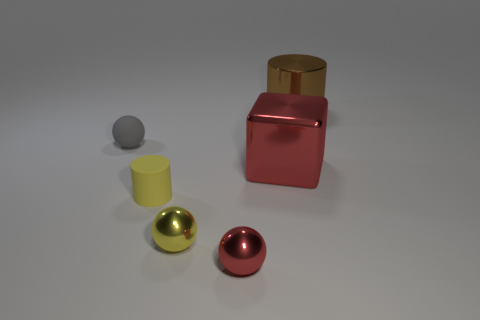There is a small thing that is the same color as the matte cylinder; what is its shape?
Ensure brevity in your answer.  Sphere. There is a tiny red metal object; is its shape the same as the matte thing that is behind the small rubber cylinder?
Your answer should be very brief. Yes. The metal thing that is both in front of the large brown shiny thing and behind the yellow matte thing is what color?
Provide a succinct answer. Red. What material is the cylinder in front of the big thing behind the rubber thing behind the tiny yellow cylinder?
Make the answer very short. Rubber. What is the gray object made of?
Keep it short and to the point. Rubber. What is the size of the yellow object that is the same shape as the large brown thing?
Your answer should be compact. Small. What number of other things are there of the same material as the yellow cylinder
Give a very brief answer. 1. Is the number of red objects to the left of the gray object the same as the number of large yellow cylinders?
Your response must be concise. Yes. Does the cylinder behind the matte sphere have the same size as the gray thing?
Keep it short and to the point. No. There is a yellow metal ball; how many small cylinders are behind it?
Provide a short and direct response. 1. 